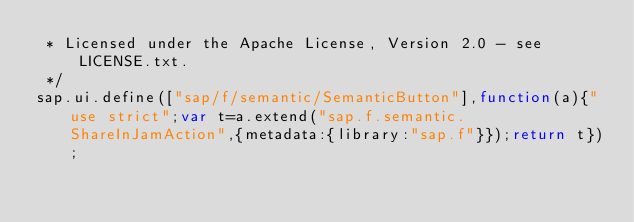Convert code to text. <code><loc_0><loc_0><loc_500><loc_500><_JavaScript_> * Licensed under the Apache License, Version 2.0 - see LICENSE.txt.
 */
sap.ui.define(["sap/f/semantic/SemanticButton"],function(a){"use strict";var t=a.extend("sap.f.semantic.ShareInJamAction",{metadata:{library:"sap.f"}});return t});</code> 